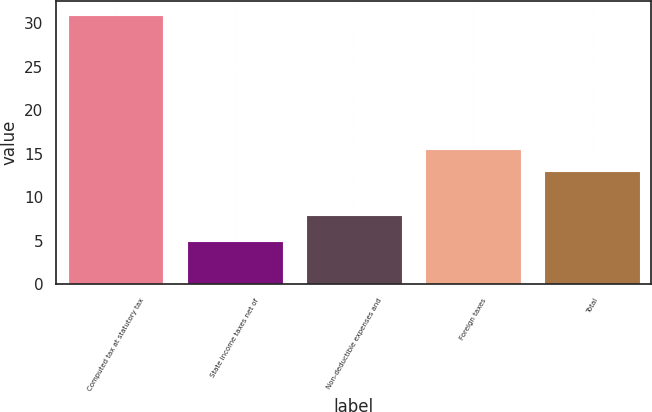Convert chart to OTSL. <chart><loc_0><loc_0><loc_500><loc_500><bar_chart><fcel>Computed tax at statutory tax<fcel>State income taxes net of<fcel>Non-deductible expenses and<fcel>Foreign taxes<fcel>Total<nl><fcel>31<fcel>5<fcel>8<fcel>15.6<fcel>13<nl></chart> 